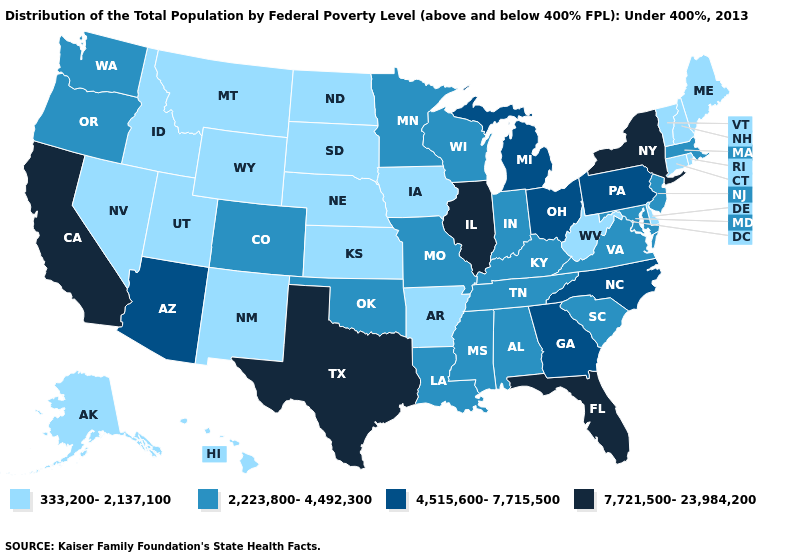What is the highest value in the West ?
Quick response, please. 7,721,500-23,984,200. Does the map have missing data?
Be succinct. No. Does Vermont have the highest value in the Northeast?
Short answer required. No. What is the highest value in the South ?
Keep it brief. 7,721,500-23,984,200. Does New Mexico have the lowest value in the USA?
Short answer required. Yes. Which states have the lowest value in the MidWest?
Give a very brief answer. Iowa, Kansas, Nebraska, North Dakota, South Dakota. Name the states that have a value in the range 333,200-2,137,100?
Concise answer only. Alaska, Arkansas, Connecticut, Delaware, Hawaii, Idaho, Iowa, Kansas, Maine, Montana, Nebraska, Nevada, New Hampshire, New Mexico, North Dakota, Rhode Island, South Dakota, Utah, Vermont, West Virginia, Wyoming. Does New York have the highest value in the USA?
Short answer required. Yes. Name the states that have a value in the range 7,721,500-23,984,200?
Concise answer only. California, Florida, Illinois, New York, Texas. What is the highest value in the MidWest ?
Write a very short answer. 7,721,500-23,984,200. Name the states that have a value in the range 4,515,600-7,715,500?
Answer briefly. Arizona, Georgia, Michigan, North Carolina, Ohio, Pennsylvania. Name the states that have a value in the range 4,515,600-7,715,500?
Answer briefly. Arizona, Georgia, Michigan, North Carolina, Ohio, Pennsylvania. What is the lowest value in the USA?
Answer briefly. 333,200-2,137,100. What is the value of New Jersey?
Short answer required. 2,223,800-4,492,300. Does the map have missing data?
Give a very brief answer. No. 